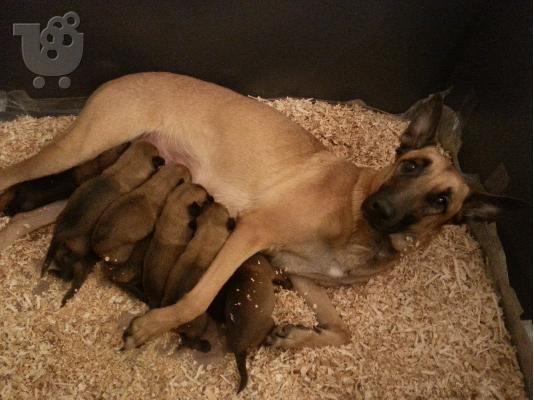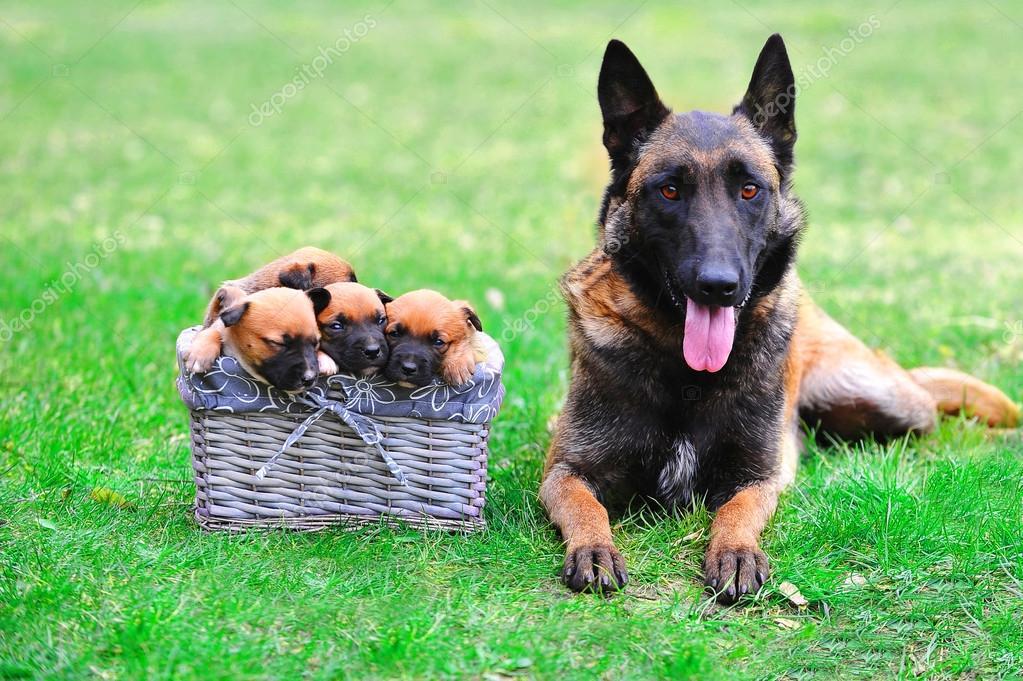The first image is the image on the left, the second image is the image on the right. Analyze the images presented: Is the assertion "There are at least six dogs." valid? Answer yes or no. Yes. The first image is the image on the left, the second image is the image on the right. Examine the images to the left and right. Is the description "Some of the German Shepherds do not have their ears clipped." accurate? Answer yes or no. Yes. 